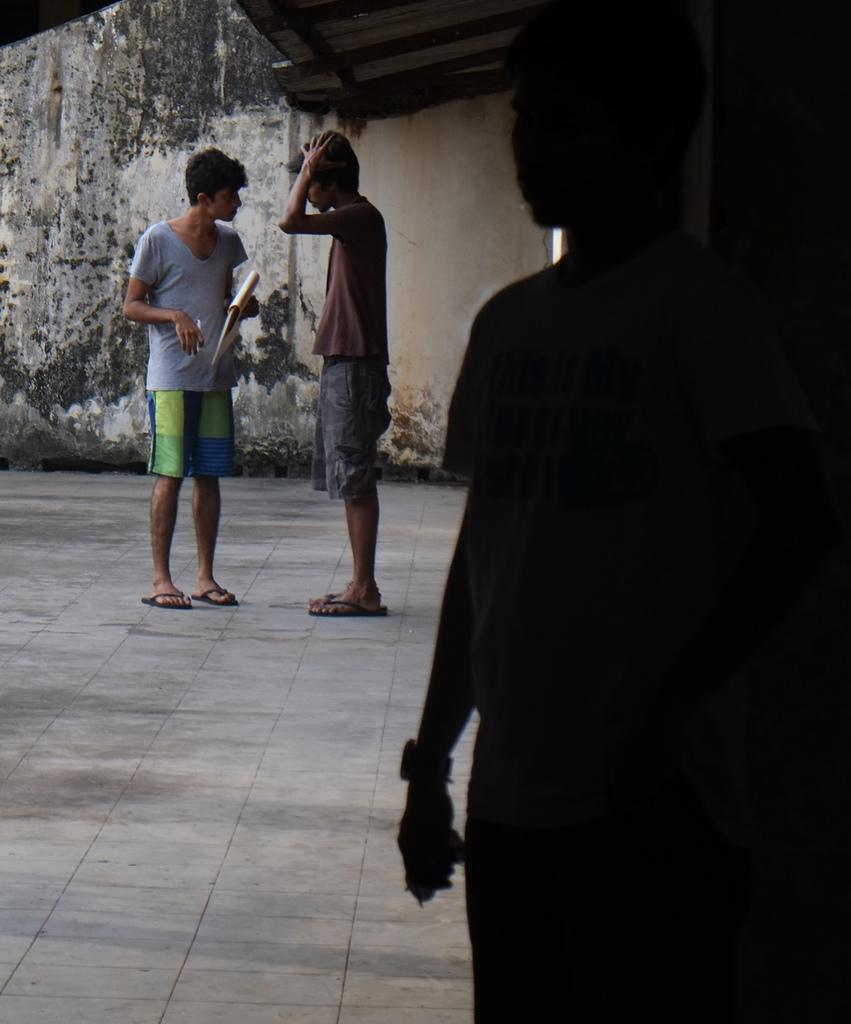Could you give a brief overview of what you see in this image? In this image, we can see three persons are standing. Here a person holding a book and pen. Background we can see wall. 